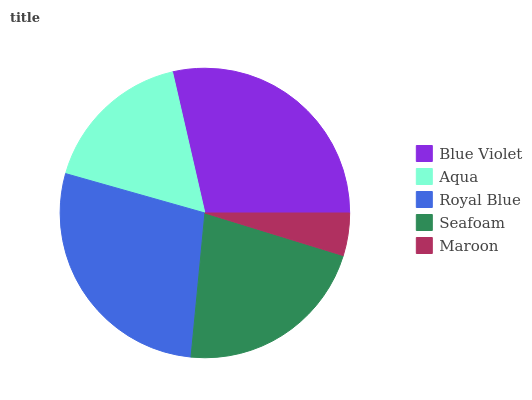Is Maroon the minimum?
Answer yes or no. Yes. Is Blue Violet the maximum?
Answer yes or no. Yes. Is Aqua the minimum?
Answer yes or no. No. Is Aqua the maximum?
Answer yes or no. No. Is Blue Violet greater than Aqua?
Answer yes or no. Yes. Is Aqua less than Blue Violet?
Answer yes or no. Yes. Is Aqua greater than Blue Violet?
Answer yes or no. No. Is Blue Violet less than Aqua?
Answer yes or no. No. Is Seafoam the high median?
Answer yes or no. Yes. Is Seafoam the low median?
Answer yes or no. Yes. Is Aqua the high median?
Answer yes or no. No. Is Blue Violet the low median?
Answer yes or no. No. 